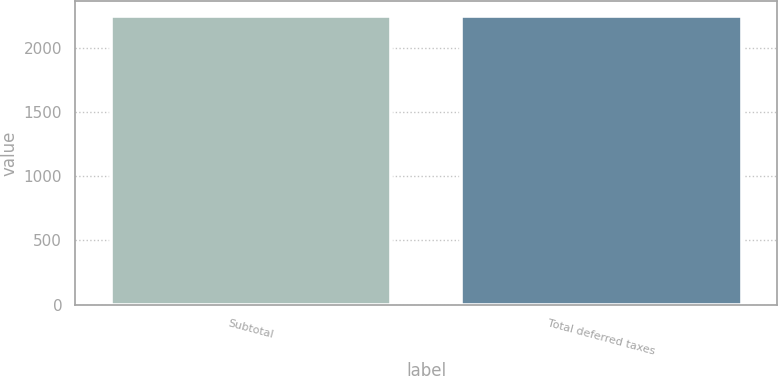Convert chart to OTSL. <chart><loc_0><loc_0><loc_500><loc_500><bar_chart><fcel>Subtotal<fcel>Total deferred taxes<nl><fcel>2250<fcel>2250.1<nl></chart> 